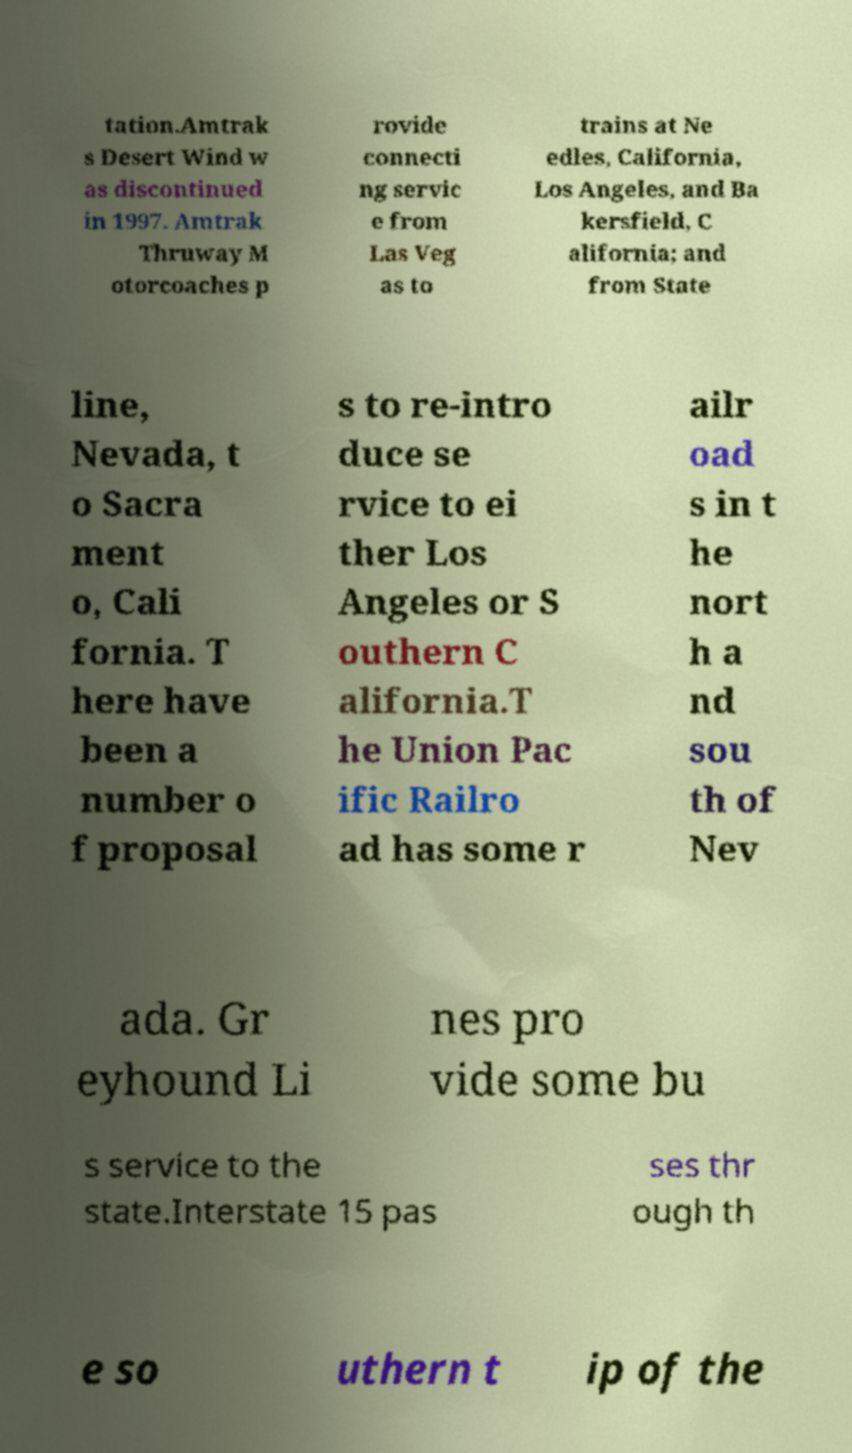Please read and relay the text visible in this image. What does it say? tation.Amtrak s Desert Wind w as discontinued in 1997. Amtrak Thruway M otorcoaches p rovide connecti ng servic e from Las Veg as to trains at Ne edles, California, Los Angeles, and Ba kersfield, C alifornia; and from State line, Nevada, t o Sacra ment o, Cali fornia. T here have been a number o f proposal s to re-intro duce se rvice to ei ther Los Angeles or S outhern C alifornia.T he Union Pac ific Railro ad has some r ailr oad s in t he nort h a nd sou th of Nev ada. Gr eyhound Li nes pro vide some bu s service to the state.Interstate 15 pas ses thr ough th e so uthern t ip of the 